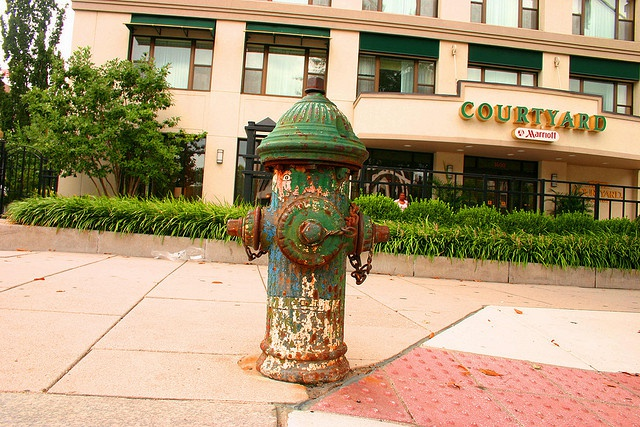Describe the objects in this image and their specific colors. I can see fire hydrant in white, olive, maroon, black, and brown tones, potted plant in white, black, olive, brown, and maroon tones, potted plant in white, darkgreen, black, and olive tones, potted plant in white, black, darkgreen, and olive tones, and potted plant in white, black, olive, darkgreen, and maroon tones in this image. 